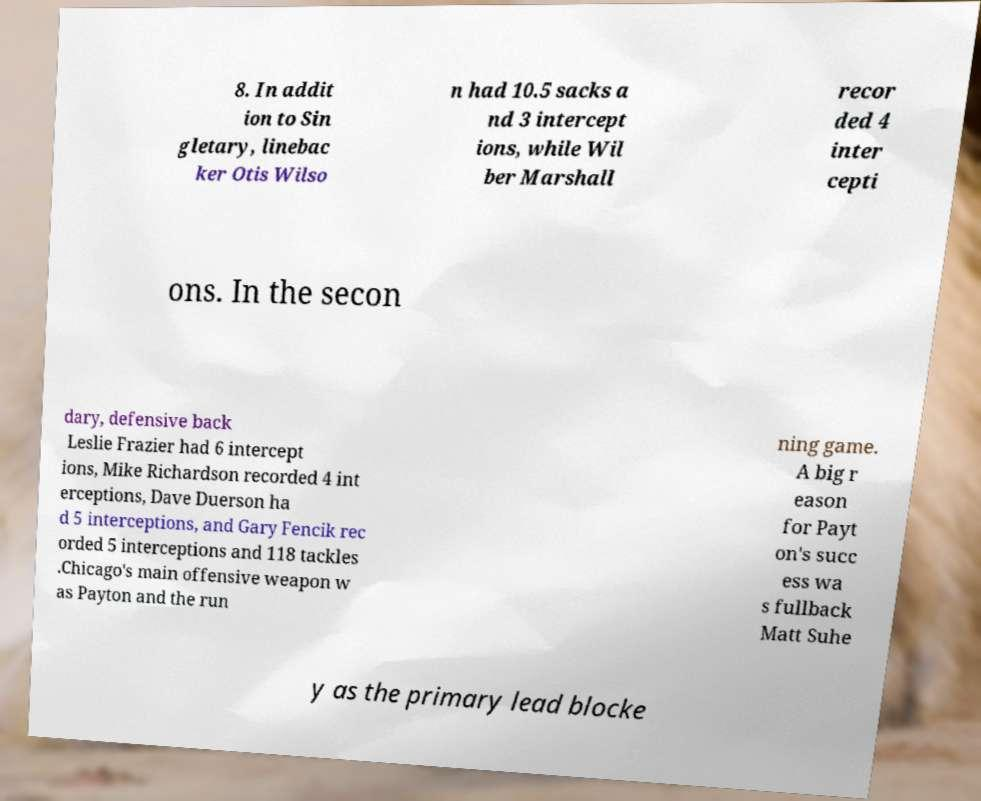Please identify and transcribe the text found in this image. 8. In addit ion to Sin gletary, linebac ker Otis Wilso n had 10.5 sacks a nd 3 intercept ions, while Wil ber Marshall recor ded 4 inter cepti ons. In the secon dary, defensive back Leslie Frazier had 6 intercept ions, Mike Richardson recorded 4 int erceptions, Dave Duerson ha d 5 interceptions, and Gary Fencik rec orded 5 interceptions and 118 tackles .Chicago's main offensive weapon w as Payton and the run ning game. A big r eason for Payt on's succ ess wa s fullback Matt Suhe y as the primary lead blocke 